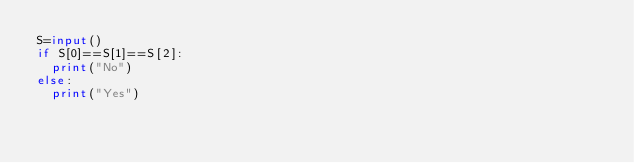<code> <loc_0><loc_0><loc_500><loc_500><_Python_>S=input()
if S[0]==S[1]==S[2]:
  print("No")
else:
  print("Yes")</code> 